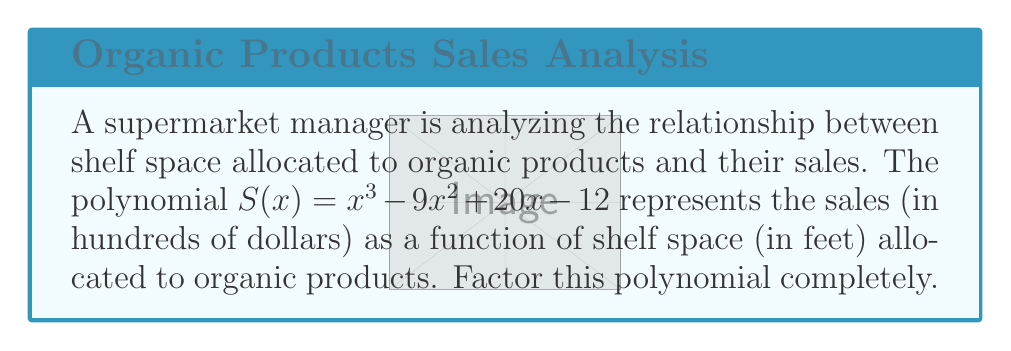Can you answer this question? Let's factor this polynomial step-by-step:

1) First, we check if there are any common factors. In this case, there are none.

2) Next, we can try to guess one of the factors. Since the constant term is -12, possible factors are ±1, ±2, ±3, ±4, ±6, ±12. Let's try these:

   $S(1) = 1 - 9 + 20 - 12 = 0$

   This means $(x-1)$ is a factor.

3) We can now use polynomial long division to divide $S(x)$ by $(x-1)$:

   $$\frac{x^3 - 9x^2 + 20x - 12}{x-1} = x^2 - 8x + 12$$

4) So now we have: $S(x) = (x-1)(x^2 - 8x + 12)$

5) The quadratic factor $x^2 - 8x + 12$ can be factored further:

   $$x^2 - 8x + 12 = (x-6)(x-2)$$

6) Therefore, the complete factorization is:

   $$S(x) = (x-1)(x-6)(x-2)$$

This factorization shows that the sales will be zero when the shelf space is 1, 2, or 6 feet, which could be useful information for the supermarket manager.
Answer: $(x-1)(x-6)(x-2)$ 